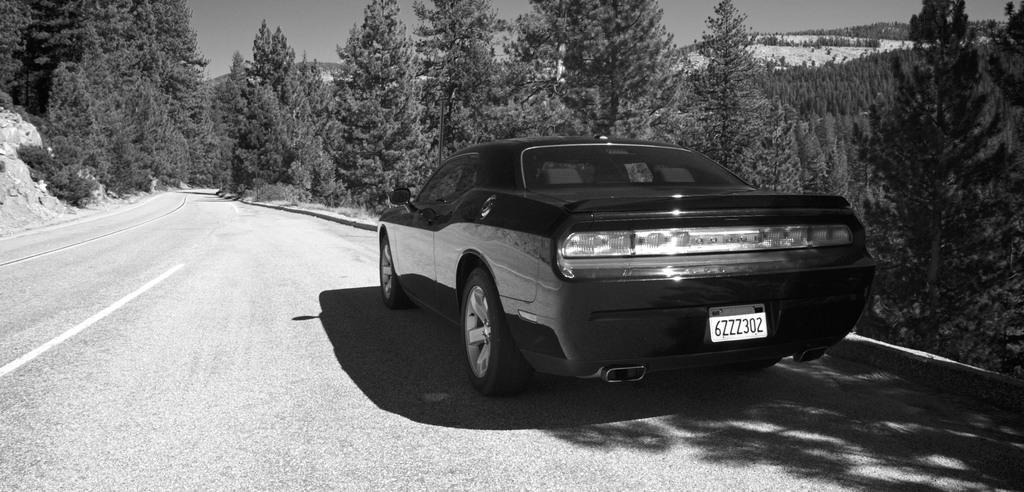Could you give a brief overview of what you see in this image? This is a black and white image where we can see a car is moving on a road. In the background, we can see trees, hills and the sky. 